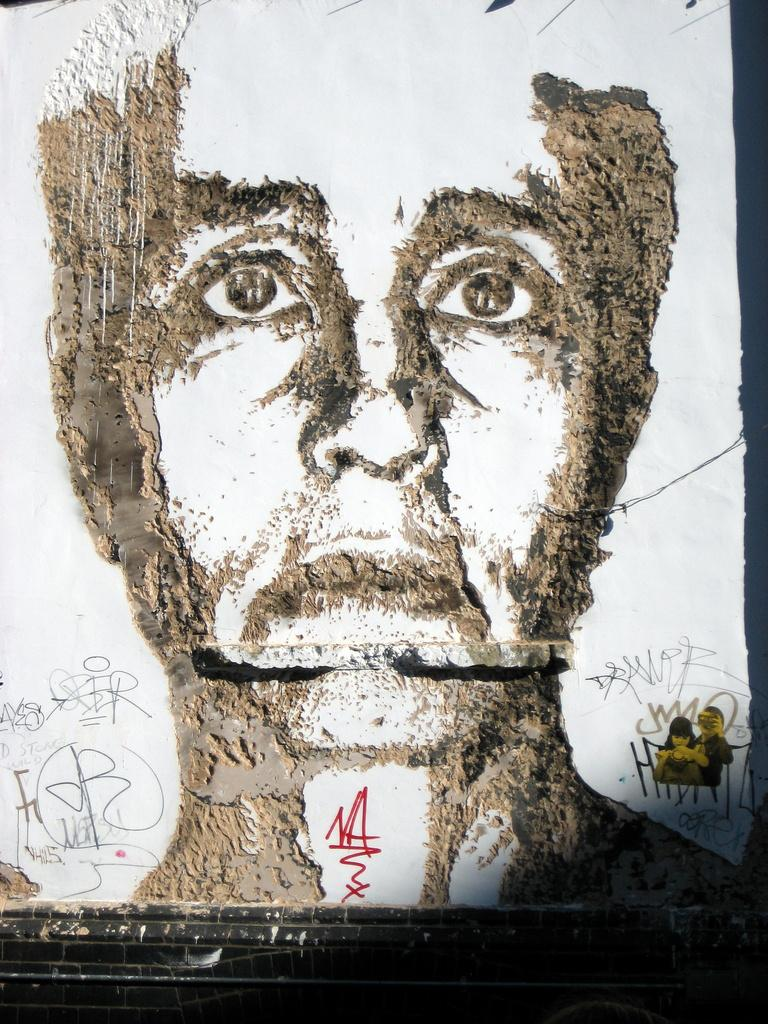What is the main subject of the image? There is a painting of a person in the image. What can be found below the painting? There is text written below the painting. How many snakes are wrapped around the person's legs in the painting? There are no snakes present in the painting; it features a person without any snakes. What type of stocking is the person wearing in the painting? There is no mention of stockings or any clothing details in the painting; it only depicts a person. 